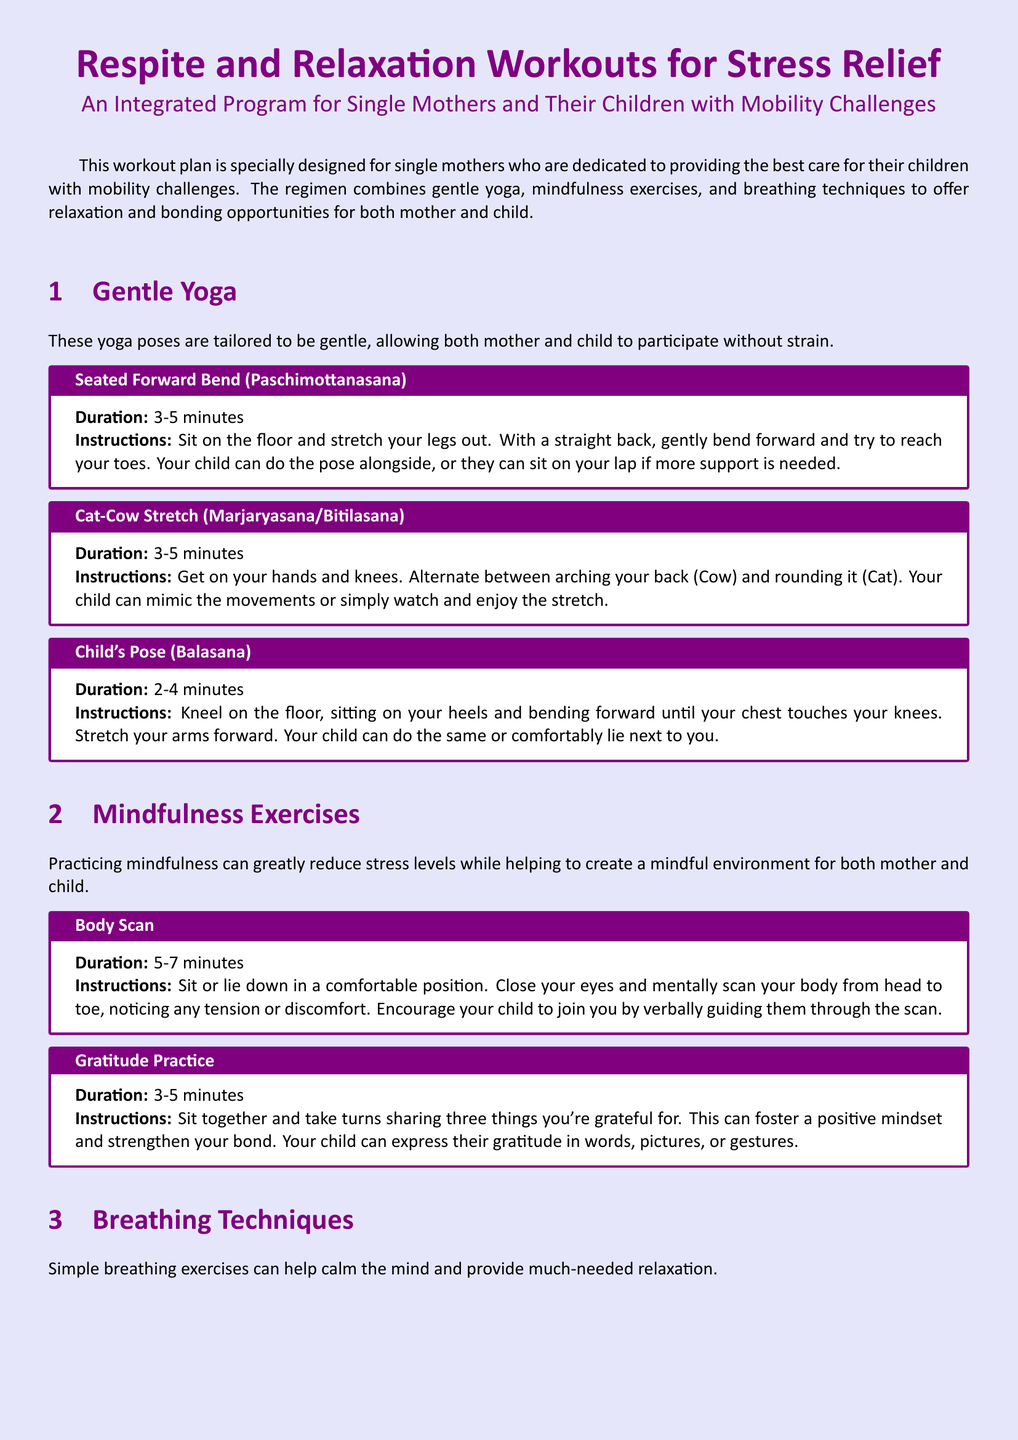What is the title of the document? The title of the document is indicated at the top of the rendered output.
Answer: Respite and Relaxation Workouts for Stress Relief How many minutes is the Body Scan mindfulness exercise? The duration is specified next to the exercise name in the document.
Answer: 5-7 minutes Which yoga pose involves sitting on the floor and stretching the legs out? The question references specific instructions found under the Gentle Yoga section.
Answer: Seated Forward Bend What breathing technique involves inhaling through the nose for a count of 4? This technique is listed in the Breathing Techniques section and requires understanding the duration sequence.
Answer: 4-7-8 Breathing What is the suggested duration for the Cat-Cow Stretch? The document provides a specific time frame for each exercise listed in the yoga section.
Answer: 3-5 minutes How many things are suggested to share during the Gratitude Practice? The number of items to share is explicitly stated within the exercise instructions.
Answer: Three What is the main purpose of the integrated workout program? The main goal is summarized in the introduction of the document, reflecting the target audience's needs.
Answer: Relaxation and stress relief What physical position is suggested for the Child's Pose? This position can be derived from the specific instructions provided for the yoga pose.
Answer: Kneeling on the floor How many different sections are there in the workout plan? The sections are listed under headings in the document and are easily identifiable.
Answer: Three 